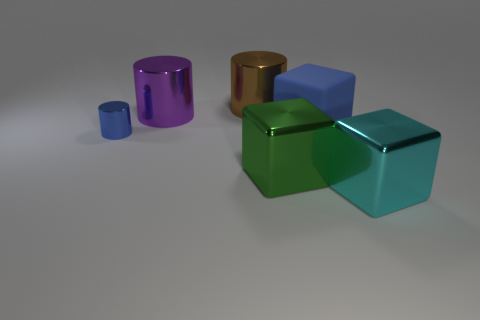Are there any other things that have the same material as the blue cube?
Your answer should be compact. No. The matte object that is the same size as the brown shiny cylinder is what color?
Make the answer very short. Blue. The brown object that is the same shape as the big purple metallic thing is what size?
Give a very brief answer. Large. What shape is the blue thing that is in front of the rubber thing?
Ensure brevity in your answer.  Cylinder. Does the cyan metallic object have the same shape as the blue thing left of the large green thing?
Your answer should be very brief. No. Are there the same number of small objects to the left of the small blue object and big brown metallic objects that are behind the brown object?
Offer a very short reply. Yes. There is another object that is the same color as the tiny metallic thing; what shape is it?
Give a very brief answer. Cube. Is the color of the shiny thing that is on the right side of the blue rubber cube the same as the cylinder to the right of the purple cylinder?
Your answer should be very brief. No. Are there more tiny cylinders behind the blue matte cube than large green metal cubes?
Provide a succinct answer. No. What material is the blue cylinder?
Your answer should be compact. Metal. 